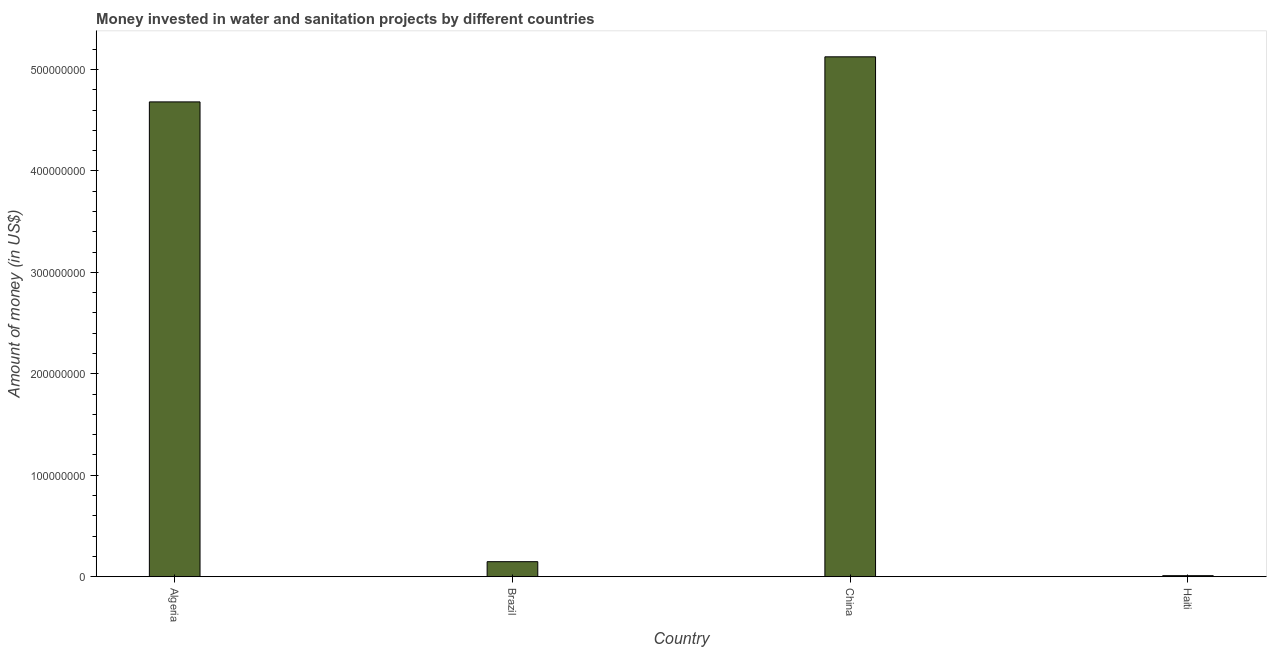What is the title of the graph?
Offer a very short reply. Money invested in water and sanitation projects by different countries. What is the label or title of the Y-axis?
Provide a short and direct response. Amount of money (in US$). What is the investment in Brazil?
Keep it short and to the point. 1.48e+07. Across all countries, what is the maximum investment?
Offer a terse response. 5.12e+08. In which country was the investment minimum?
Give a very brief answer. Haiti. What is the sum of the investment?
Provide a succinct answer. 9.96e+08. What is the difference between the investment in Algeria and China?
Offer a very short reply. -4.44e+07. What is the average investment per country?
Offer a very short reply. 2.49e+08. What is the median investment?
Give a very brief answer. 2.41e+08. What is the ratio of the investment in Algeria to that in Brazil?
Provide a succinct answer. 31.62. Is the investment in Algeria less than that in Brazil?
Keep it short and to the point. No. What is the difference between the highest and the second highest investment?
Your response must be concise. 4.44e+07. What is the difference between the highest and the lowest investment?
Offer a terse response. 5.11e+08. In how many countries, is the investment greater than the average investment taken over all countries?
Offer a very short reply. 2. Are the values on the major ticks of Y-axis written in scientific E-notation?
Keep it short and to the point. No. What is the Amount of money (in US$) of Algeria?
Your answer should be compact. 4.68e+08. What is the Amount of money (in US$) in Brazil?
Offer a very short reply. 1.48e+07. What is the Amount of money (in US$) in China?
Make the answer very short. 5.12e+08. What is the difference between the Amount of money (in US$) in Algeria and Brazil?
Make the answer very short. 4.53e+08. What is the difference between the Amount of money (in US$) in Algeria and China?
Your answer should be compact. -4.44e+07. What is the difference between the Amount of money (in US$) in Algeria and Haiti?
Your answer should be very brief. 4.67e+08. What is the difference between the Amount of money (in US$) in Brazil and China?
Keep it short and to the point. -4.98e+08. What is the difference between the Amount of money (in US$) in Brazil and Haiti?
Your answer should be compact. 1.38e+07. What is the difference between the Amount of money (in US$) in China and Haiti?
Keep it short and to the point. 5.11e+08. What is the ratio of the Amount of money (in US$) in Algeria to that in Brazil?
Your answer should be very brief. 31.62. What is the ratio of the Amount of money (in US$) in Algeria to that in China?
Offer a terse response. 0.91. What is the ratio of the Amount of money (in US$) in Algeria to that in Haiti?
Ensure brevity in your answer.  468. What is the ratio of the Amount of money (in US$) in Brazil to that in China?
Your answer should be very brief. 0.03. What is the ratio of the Amount of money (in US$) in Brazil to that in Haiti?
Your response must be concise. 14.8. What is the ratio of the Amount of money (in US$) in China to that in Haiti?
Your answer should be very brief. 512.43. 